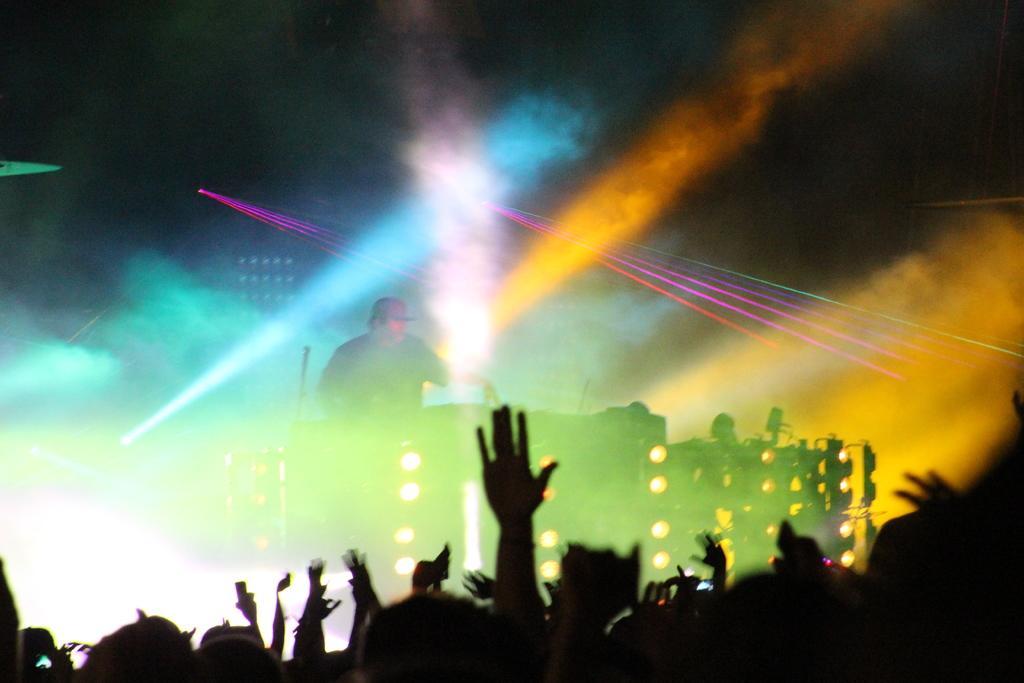In one or two sentences, can you explain what this image depicts? In this image I can see a concert is going on. People are present at the front. There are lights and a person is standing on the stage. There are lights and smoke at the back. 